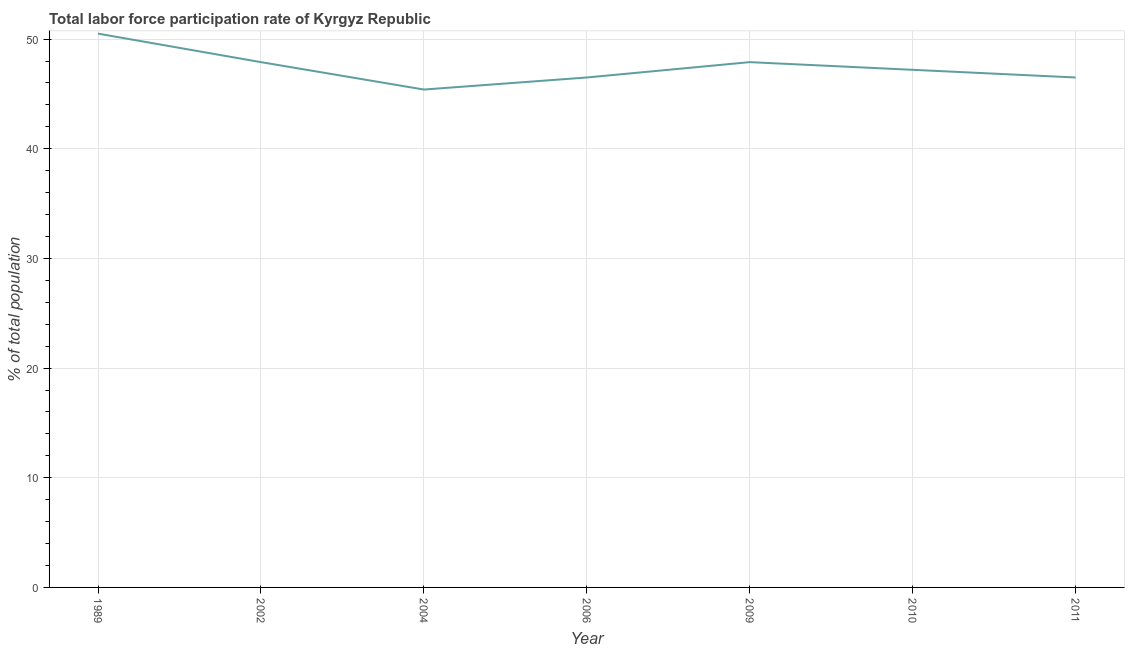What is the total labor force participation rate in 2010?
Make the answer very short. 47.2. Across all years, what is the maximum total labor force participation rate?
Your response must be concise. 50.5. Across all years, what is the minimum total labor force participation rate?
Your response must be concise. 45.4. In which year was the total labor force participation rate maximum?
Ensure brevity in your answer.  1989. What is the sum of the total labor force participation rate?
Your answer should be very brief. 331.9. What is the average total labor force participation rate per year?
Provide a succinct answer. 47.41. What is the median total labor force participation rate?
Your answer should be very brief. 47.2. In how many years, is the total labor force participation rate greater than 44 %?
Your answer should be compact. 7. Do a majority of the years between 2010 and 2004 (inclusive) have total labor force participation rate greater than 42 %?
Your answer should be compact. Yes. What is the ratio of the total labor force participation rate in 2002 to that in 2004?
Your answer should be very brief. 1.06. What is the difference between the highest and the second highest total labor force participation rate?
Your answer should be very brief. 2.6. What is the difference between the highest and the lowest total labor force participation rate?
Provide a succinct answer. 5.1. In how many years, is the total labor force participation rate greater than the average total labor force participation rate taken over all years?
Provide a short and direct response. 3. Does the total labor force participation rate monotonically increase over the years?
Your answer should be very brief. No. How many lines are there?
Offer a terse response. 1. How many years are there in the graph?
Make the answer very short. 7. What is the difference between two consecutive major ticks on the Y-axis?
Provide a succinct answer. 10. Are the values on the major ticks of Y-axis written in scientific E-notation?
Offer a very short reply. No. Does the graph contain any zero values?
Make the answer very short. No. What is the title of the graph?
Ensure brevity in your answer.  Total labor force participation rate of Kyrgyz Republic. What is the label or title of the Y-axis?
Ensure brevity in your answer.  % of total population. What is the % of total population in 1989?
Ensure brevity in your answer.  50.5. What is the % of total population in 2002?
Keep it short and to the point. 47.9. What is the % of total population in 2004?
Your answer should be very brief. 45.4. What is the % of total population in 2006?
Your answer should be compact. 46.5. What is the % of total population of 2009?
Your answer should be very brief. 47.9. What is the % of total population in 2010?
Ensure brevity in your answer.  47.2. What is the % of total population in 2011?
Your answer should be compact. 46.5. What is the difference between the % of total population in 1989 and 2004?
Give a very brief answer. 5.1. What is the difference between the % of total population in 1989 and 2006?
Provide a succinct answer. 4. What is the difference between the % of total population in 1989 and 2010?
Offer a terse response. 3.3. What is the difference between the % of total population in 1989 and 2011?
Your answer should be compact. 4. What is the difference between the % of total population in 2002 and 2009?
Your answer should be compact. 0. What is the difference between the % of total population in 2002 and 2011?
Offer a terse response. 1.4. What is the difference between the % of total population in 2004 and 2010?
Provide a succinct answer. -1.8. What is the difference between the % of total population in 2006 and 2010?
Offer a terse response. -0.7. What is the difference between the % of total population in 2009 and 2011?
Your answer should be very brief. 1.4. What is the difference between the % of total population in 2010 and 2011?
Your answer should be very brief. 0.7. What is the ratio of the % of total population in 1989 to that in 2002?
Your answer should be very brief. 1.05. What is the ratio of the % of total population in 1989 to that in 2004?
Provide a succinct answer. 1.11. What is the ratio of the % of total population in 1989 to that in 2006?
Make the answer very short. 1.09. What is the ratio of the % of total population in 1989 to that in 2009?
Offer a very short reply. 1.05. What is the ratio of the % of total population in 1989 to that in 2010?
Offer a terse response. 1.07. What is the ratio of the % of total population in 1989 to that in 2011?
Offer a very short reply. 1.09. What is the ratio of the % of total population in 2002 to that in 2004?
Provide a short and direct response. 1.05. What is the ratio of the % of total population in 2002 to that in 2009?
Provide a succinct answer. 1. What is the ratio of the % of total population in 2002 to that in 2010?
Your answer should be very brief. 1.01. What is the ratio of the % of total population in 2004 to that in 2006?
Your answer should be compact. 0.98. What is the ratio of the % of total population in 2004 to that in 2009?
Your answer should be compact. 0.95. What is the ratio of the % of total population in 2004 to that in 2010?
Keep it short and to the point. 0.96. What is the ratio of the % of total population in 2004 to that in 2011?
Ensure brevity in your answer.  0.98. What is the ratio of the % of total population in 2006 to that in 2010?
Your answer should be very brief. 0.98. What is the ratio of the % of total population in 2006 to that in 2011?
Offer a terse response. 1. What is the ratio of the % of total population in 2009 to that in 2010?
Give a very brief answer. 1.01. What is the ratio of the % of total population in 2009 to that in 2011?
Make the answer very short. 1.03. 